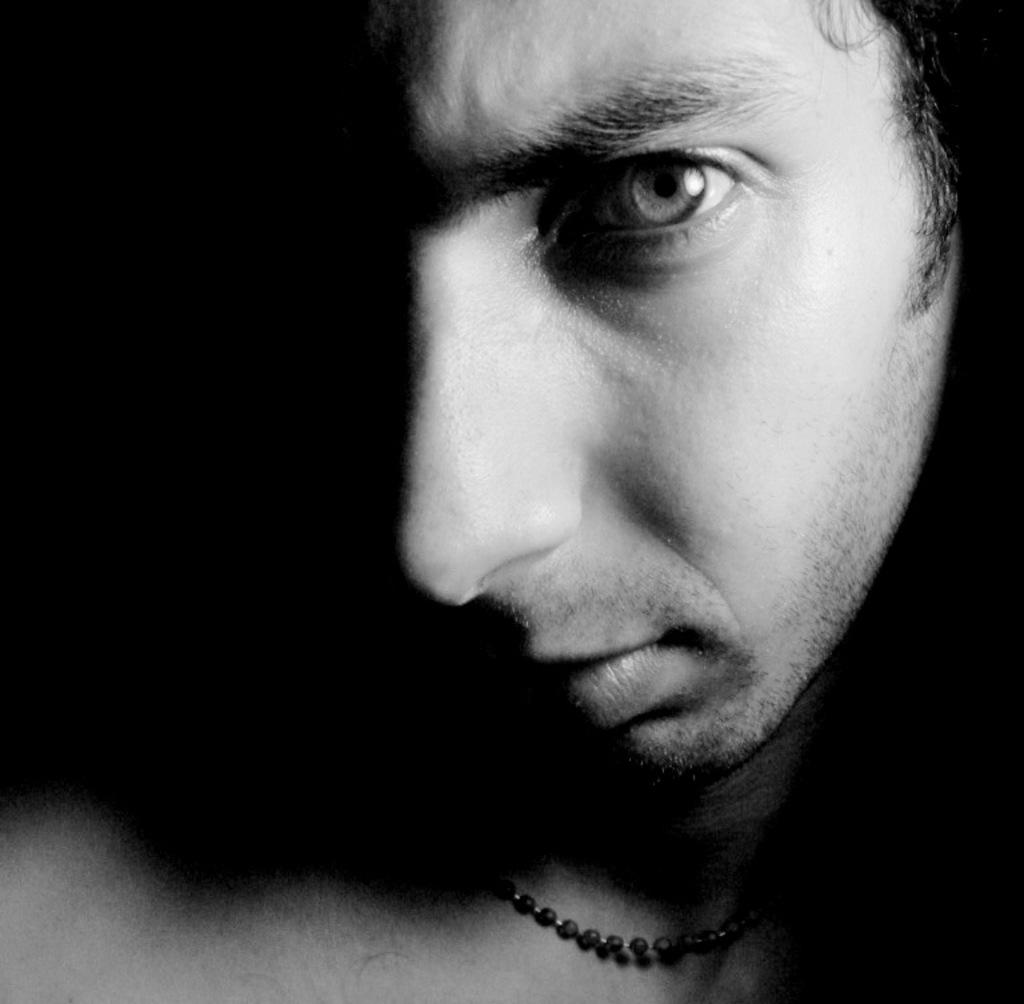What is the color scheme of the image? The image is black and white. Can you describe the person in the image? There is a person in the image. What accessory is the person wearing? The person is wearing a beaded chain. What is the color of the background in the image? The background of the image is black. What type of pancake is the person holding in the image? There is no pancake present in the image. Is the person wearing a crown in the image? There is no crown visible in the image. 